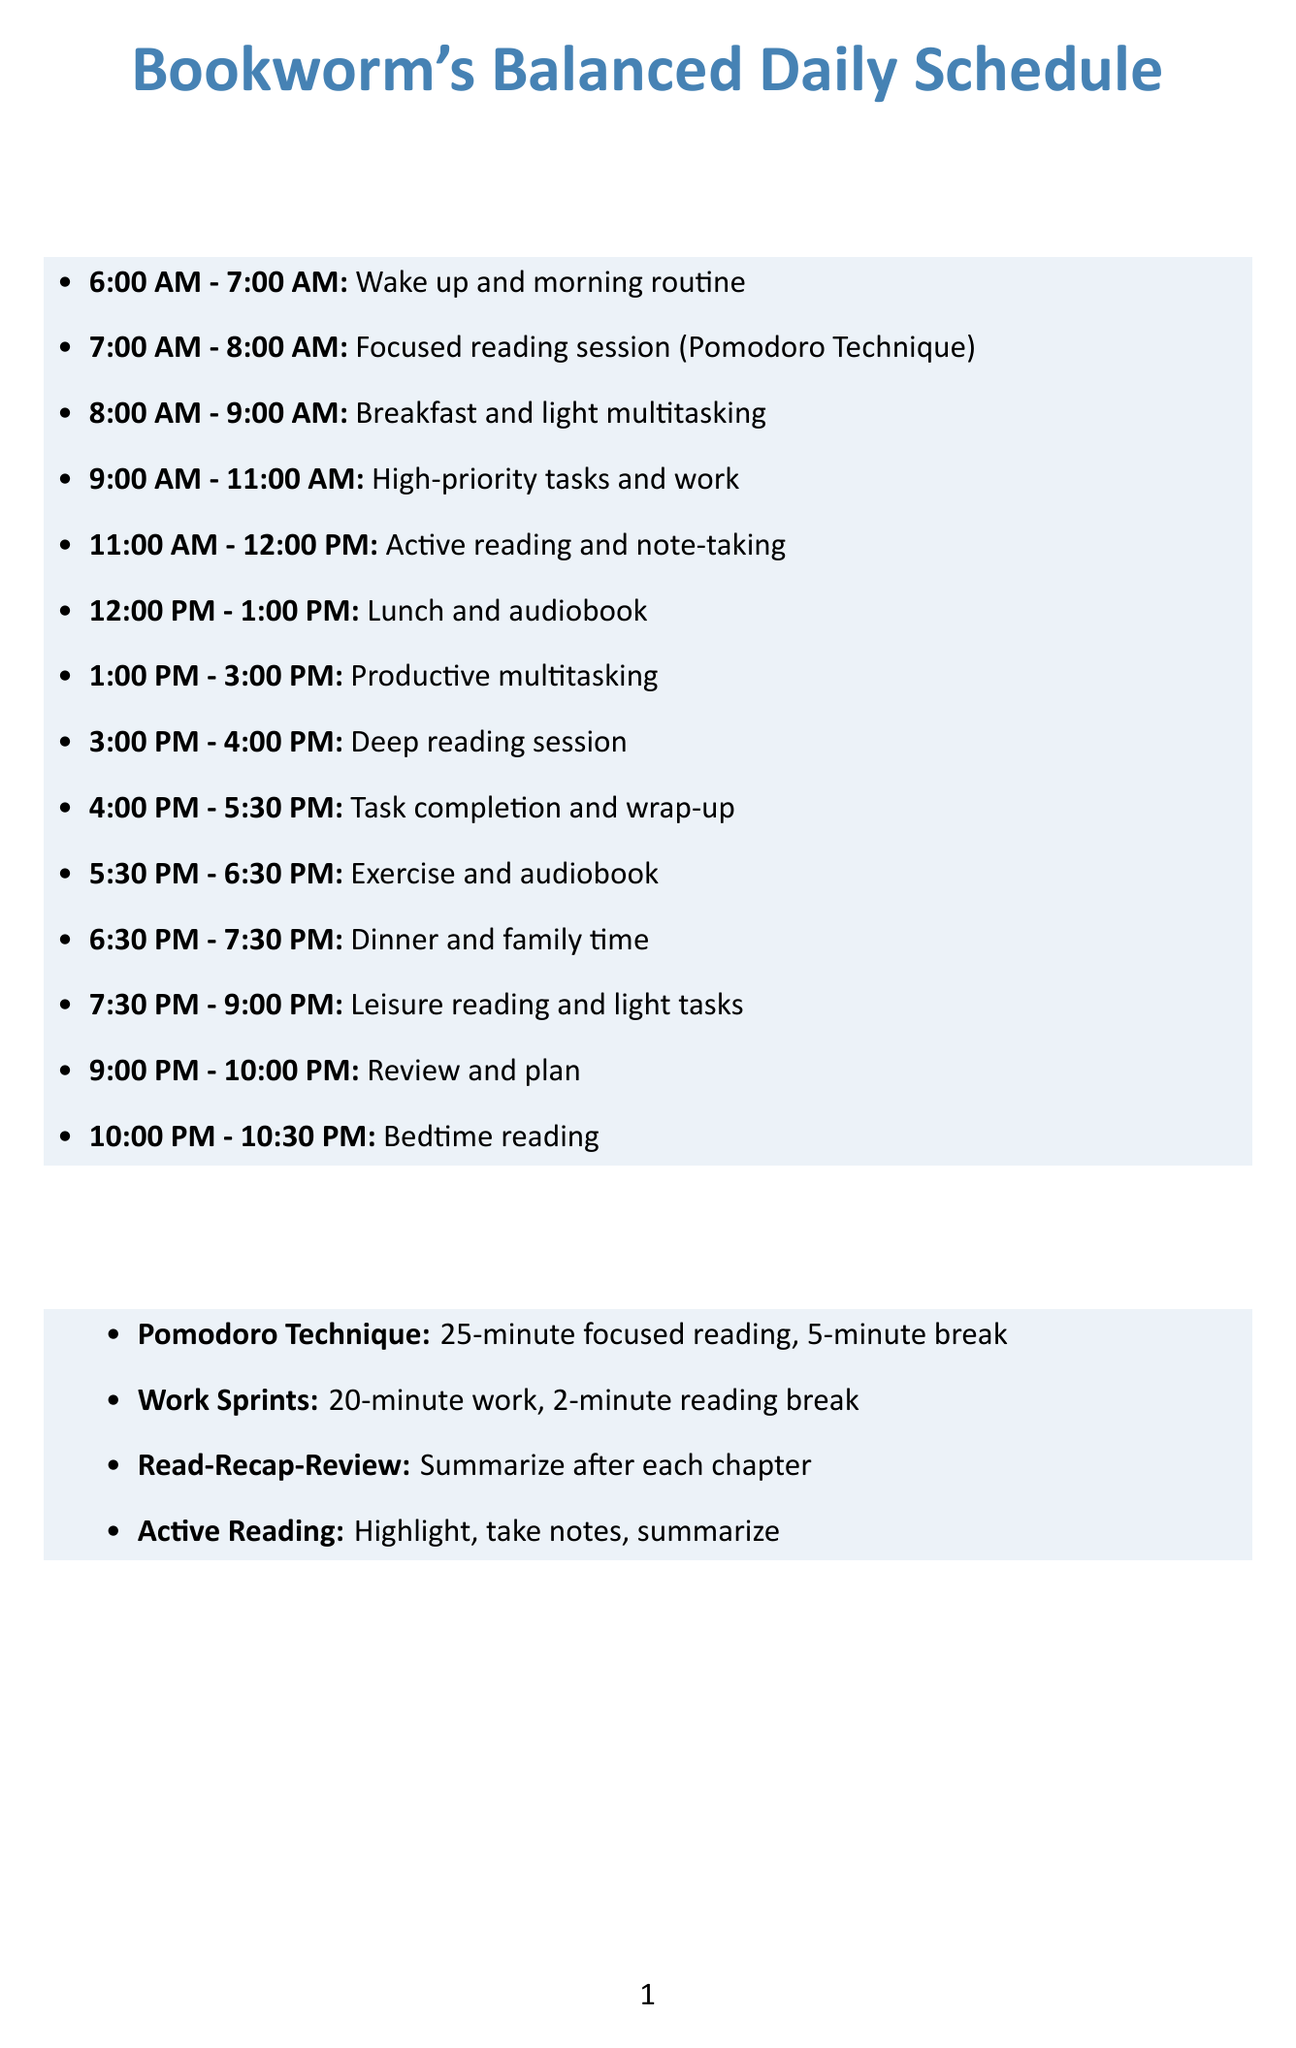What time is the focused reading session scheduled? The focused reading session is set in the time slot from 7:00 AM to 8:00 AM.
Answer: 7:00 AM - 8:00 AM What activity is suggested during lunch? The schedule suggests listening to an audiobook during lunch.
Answer: Audiobook What technique is recommended for the deep reading session? The document indicates the use of the 'Read-Recap-Review' method during the deep reading session.
Answer: Read-Recap-Review How long is the exercise and audiobook activity? The exercise and audiobook activity lasts for one hour, from 5:30 PM to 6:30 PM.
Answer: One hour What is one multitasking tip mentioned? One of the multitasking tips given is to "Use task batching."
Answer: Use task batching During what time is active reading and note-taking scheduled? The active reading and note-taking activity takes place from 11:00 AM to 12:00 PM.
Answer: 11:00 AM - 12:00 PM What do the 'work sprints' consist of? The 'work sprints' consist of alternating between 20-minute work periods and 2-minute reading breaks.
Answer: 20-minute work, 2-minute reading break What is intended to be discussed during dinner? The schedule suggests discussing interesting facts from recent readings during dinner.
Answer: Interesting facts from recent readings 